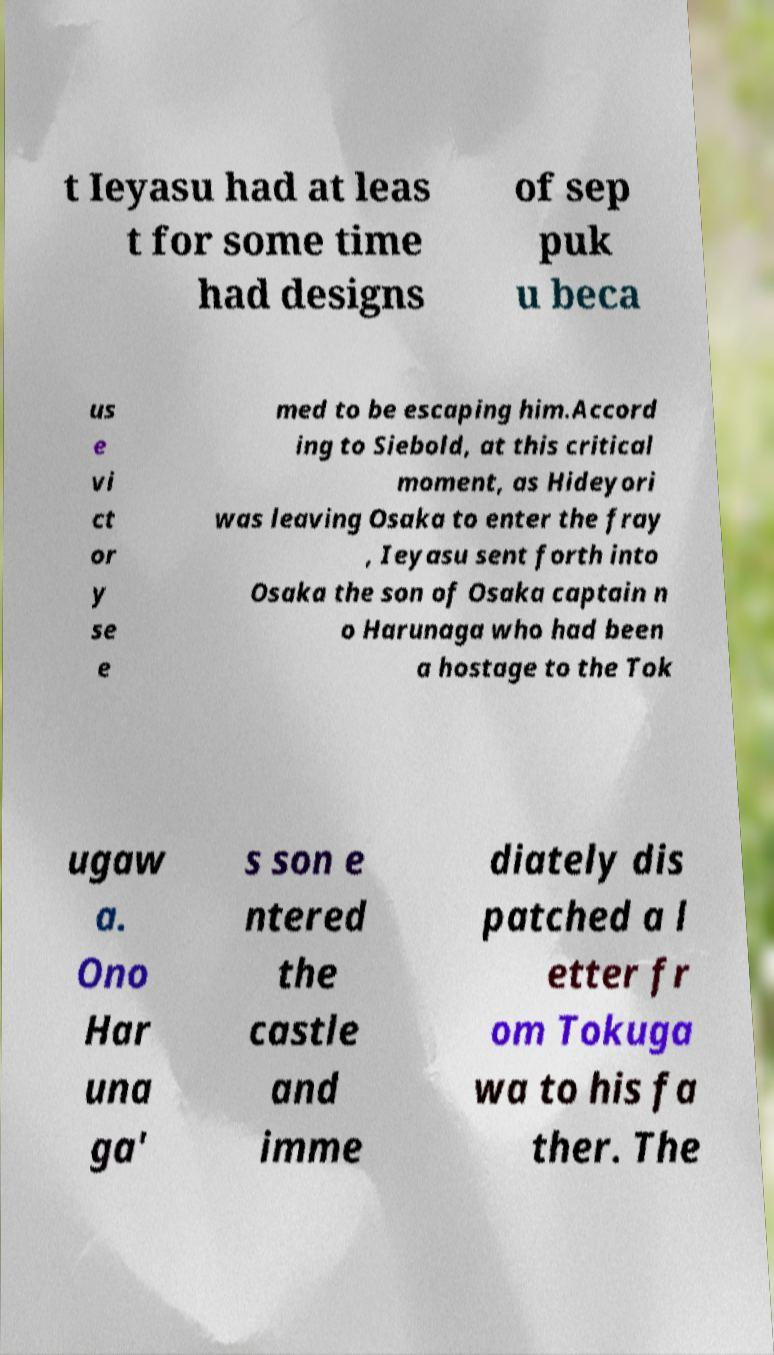Please identify and transcribe the text found in this image. t Ieyasu had at leas t for some time had designs of sep puk u beca us e vi ct or y se e med to be escaping him.Accord ing to Siebold, at this critical moment, as Hideyori was leaving Osaka to enter the fray , Ieyasu sent forth into Osaka the son of Osaka captain n o Harunaga who had been a hostage to the Tok ugaw a. Ono Har una ga' s son e ntered the castle and imme diately dis patched a l etter fr om Tokuga wa to his fa ther. The 